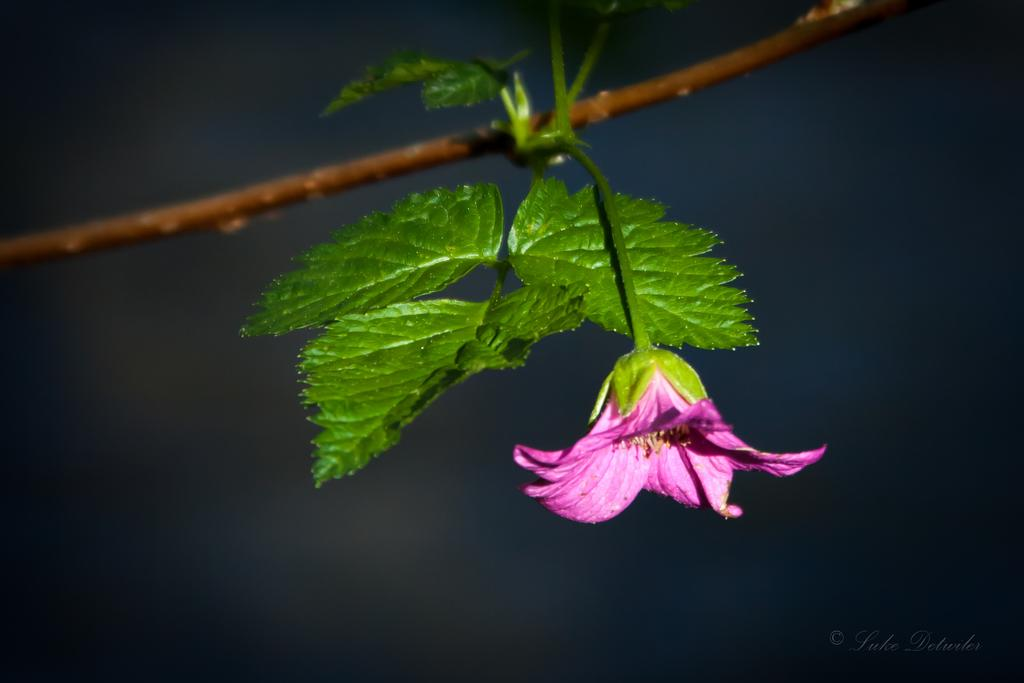What is present on the tree branch in the image? There is a tree branch in the image, and it has a flower. What color is the flower on the tree branch? The flower is purple in color. Are there any other parts of the tree branch visible in the image? Yes, there are leaves on the tree branch. What type of business is being conducted under the tree branch in the image? There is no indication of any business being conducted in the image; it features a tree branch with a flower and leaves. Who is in control of the flower on the tree branch in the image? The image does not depict any person or entity in control of the flower; it is a natural object. 